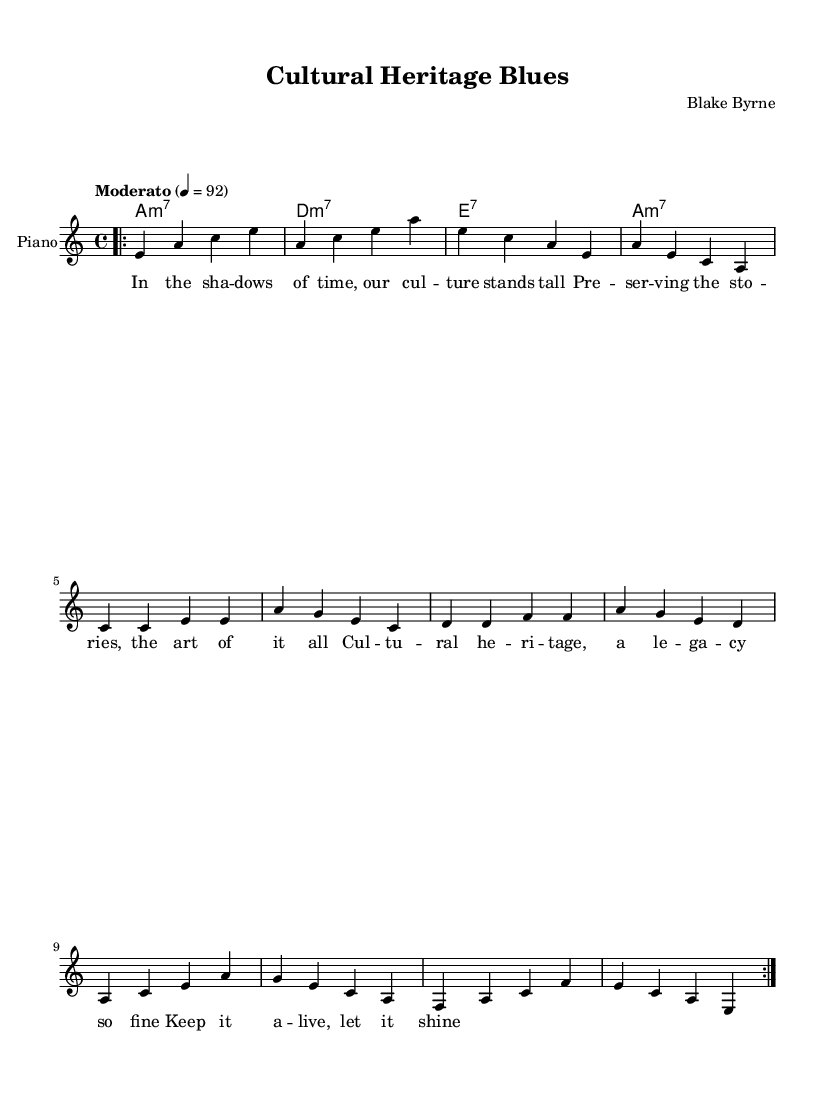What is the key signature of this music? The key signature appears at the beginning of the staff after the clef, indicating A minor, which has no sharps or flats in its key signature.
Answer: A minor What is the time signature of this composition? The time signature is shown at the start of the piece, represented by 4/4, which means there are four beats per measure and a quarter note gets one beat.
Answer: 4/4 What is the tempo marking of the piece? The tempo marking is provided in the header with the description of "Moderato" and a metronome marking of 92 beats per minute, indicating a moderate speed for the performance.
Answer: Moderato How many measures are in the verse? The verse contains four measures, which can be counted by identifying the sections in the melody labeled as "Verse" and noting the number of measures.
Answer: Four What is the chord progression for the chorus? The chords for the chorus can be found by looking at the harmonies section and reading through the chord symbols in the specified measures in the score, which are A minor, G, F, and E major.
Answer: A minor, G, F, E What is the theme of the lyrics being represented musically? The lyrics reflect on cultural preservation, as indicated by phrases discussing culture, legacy, and keeping it alive, which connects to the blues tradition of storytelling.
Answer: Cultural preservation Which musical form does this composition resemble? This composition follows a common blues form, traditionally structured with verses followed by a repeated chorus, indicative of the 12-bar blues style that emphasizes lyrical storytelling.
Answer: Blues form 